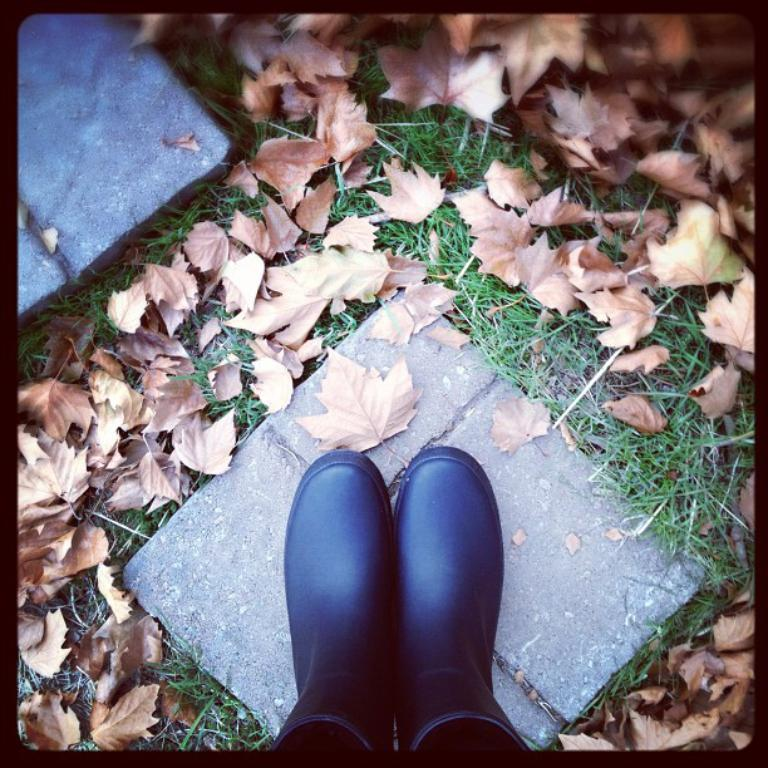What can be seen in the foreground of the picture? There are two legs of a person in the foreground of the picture. What type of natural elements are present in the image? Dry leaves and grass are visible in the image. What type of flooring is present in the image? Tiles are present in the image. What is the color of the border surrounding the image? The picture has a black border. What type of stove can be seen in the image? There is no stove present in the image. Can you describe the band playing in the background of the image? There is no band present in the image. 